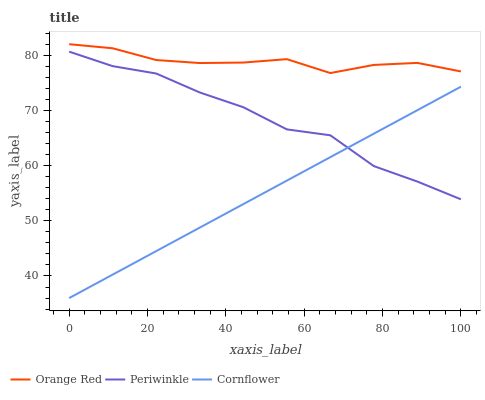Does Cornflower have the minimum area under the curve?
Answer yes or no. Yes. Does Orange Red have the maximum area under the curve?
Answer yes or no. Yes. Does Periwinkle have the minimum area under the curve?
Answer yes or no. No. Does Periwinkle have the maximum area under the curve?
Answer yes or no. No. Is Cornflower the smoothest?
Answer yes or no. Yes. Is Periwinkle the roughest?
Answer yes or no. Yes. Is Orange Red the smoothest?
Answer yes or no. No. Is Orange Red the roughest?
Answer yes or no. No. Does Periwinkle have the lowest value?
Answer yes or no. No. Does Orange Red have the highest value?
Answer yes or no. Yes. Does Periwinkle have the highest value?
Answer yes or no. No. Is Periwinkle less than Orange Red?
Answer yes or no. Yes. Is Orange Red greater than Cornflower?
Answer yes or no. Yes. Does Periwinkle intersect Orange Red?
Answer yes or no. No. 